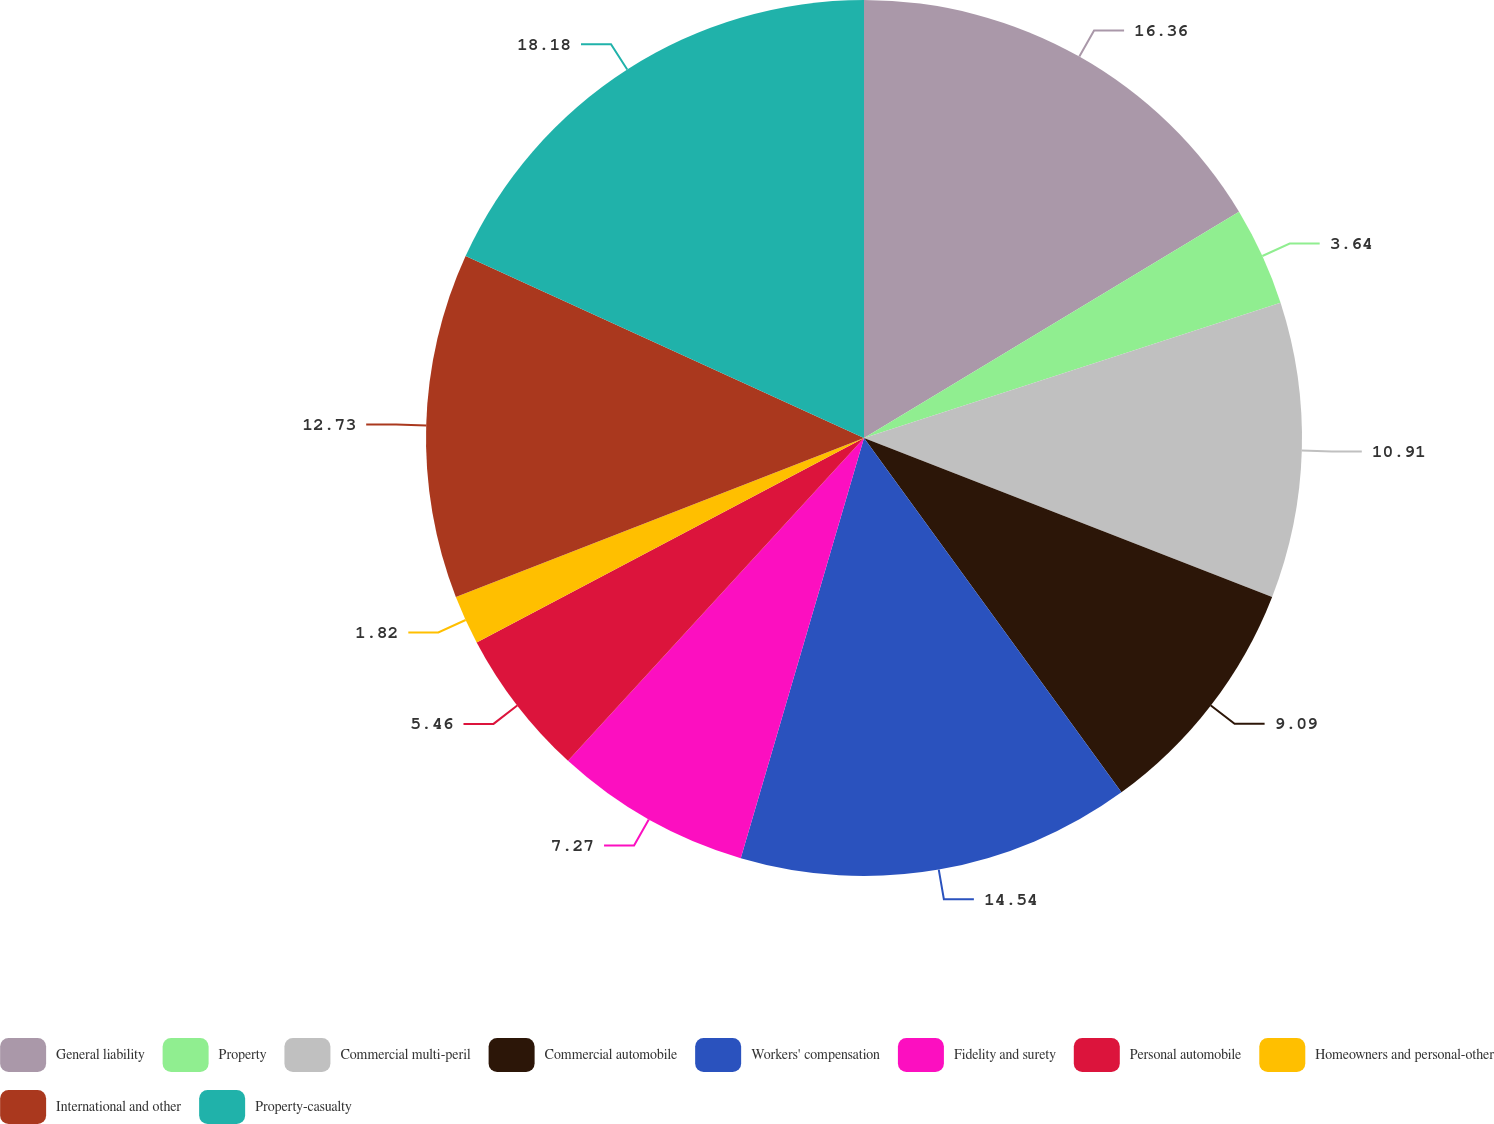<chart> <loc_0><loc_0><loc_500><loc_500><pie_chart><fcel>General liability<fcel>Property<fcel>Commercial multi-peril<fcel>Commercial automobile<fcel>Workers' compensation<fcel>Fidelity and surety<fcel>Personal automobile<fcel>Homeowners and personal-other<fcel>International and other<fcel>Property-casualty<nl><fcel>16.36%<fcel>3.64%<fcel>10.91%<fcel>9.09%<fcel>14.54%<fcel>7.27%<fcel>5.46%<fcel>1.82%<fcel>12.73%<fcel>18.18%<nl></chart> 